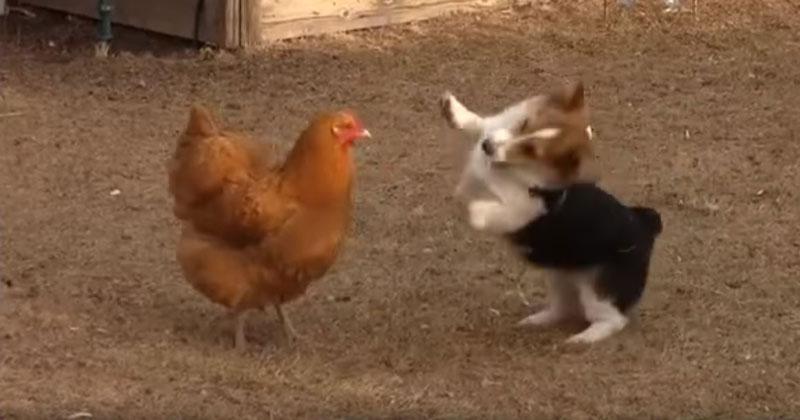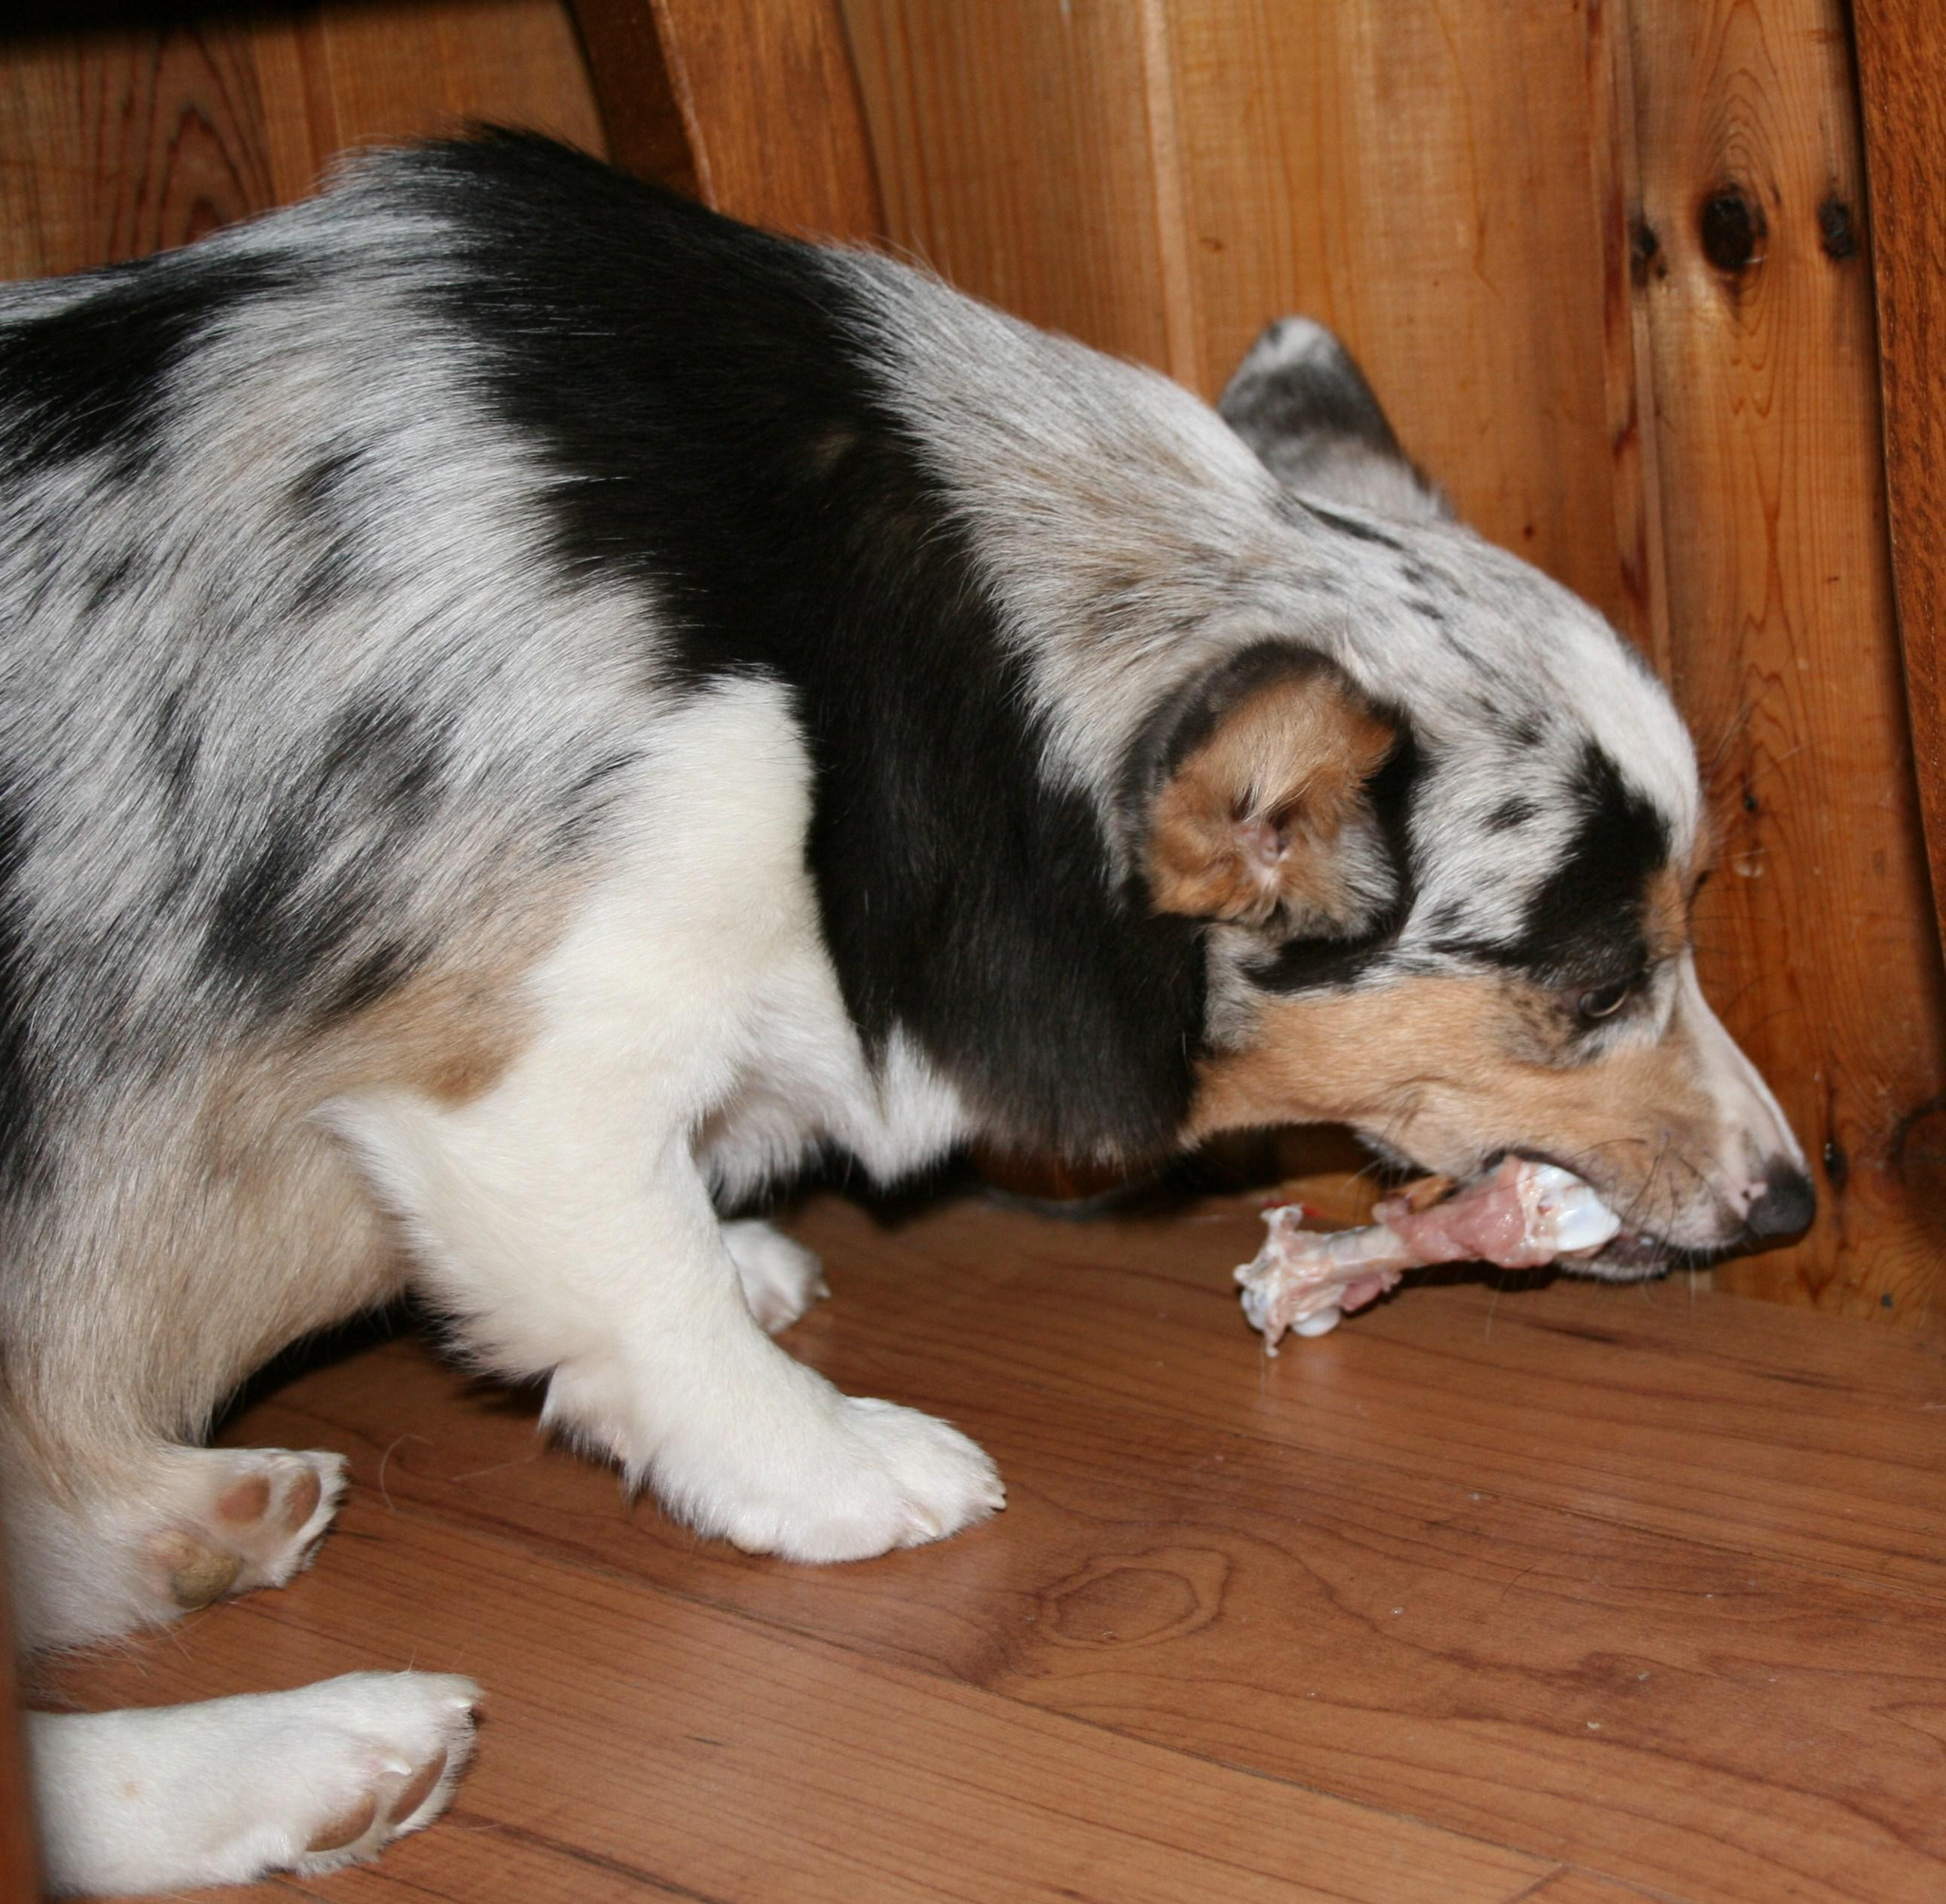The first image is the image on the left, the second image is the image on the right. For the images shown, is this caption "there is a dog and a chicken  in a dirt yard" true? Answer yes or no. Yes. The first image is the image on the left, the second image is the image on the right. Assess this claim about the two images: "In one of the images there is a dog facing a chicken.". Correct or not? Answer yes or no. Yes. 